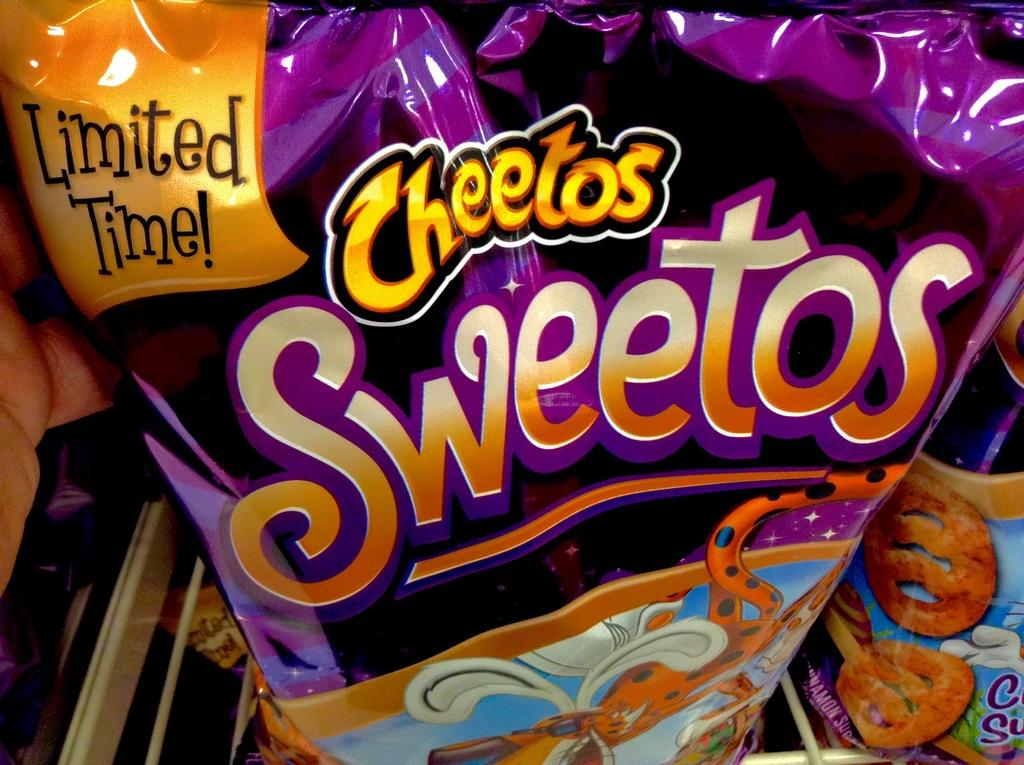What is present on the packet in the image? There is text on a packet in the image. What type of curtain is hanging in the bedroom in the image? There is no mention of a curtain or a bedroom in the image; the image only contains a packet with text. 